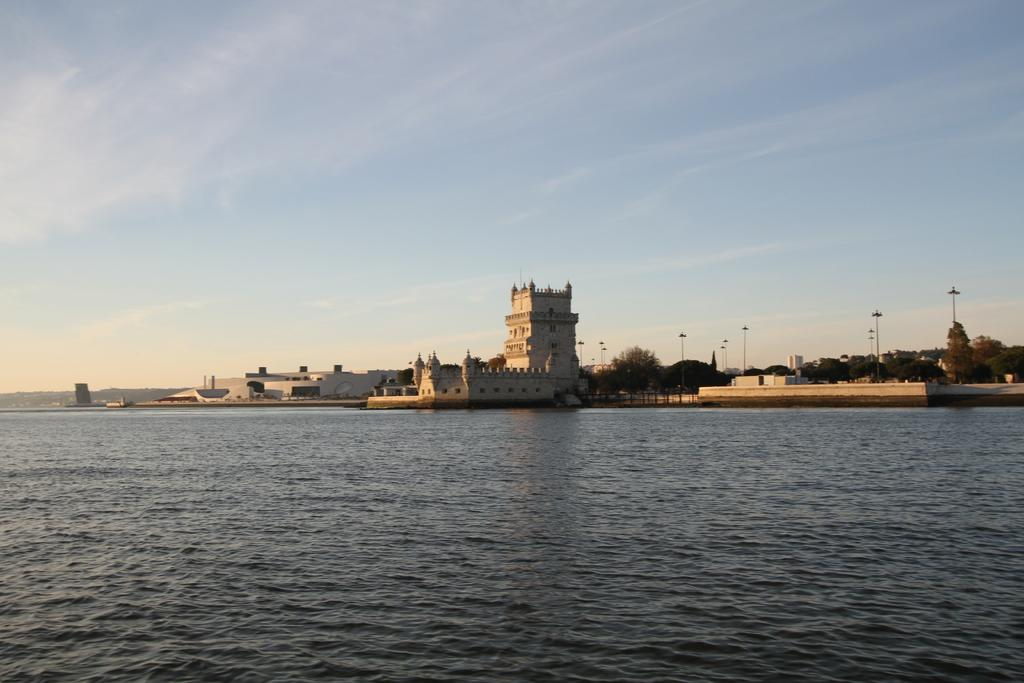What is in the foreground of the picture? There is a water body in the foreground of the picture. What can be seen in the center of the picture? Buildings, trees, street lights, and other objects are visible in the center of the picture. What is visible in the background of the picture? The sky is visible in the background of the picture. What type of attraction can be seen in the water body in the image? There is no specific attraction mentioned in the image; it only shows a water body in the foreground. Can you see any skateboarders in the image? There is no mention of skateboarders or any skate-related objects in the image. 